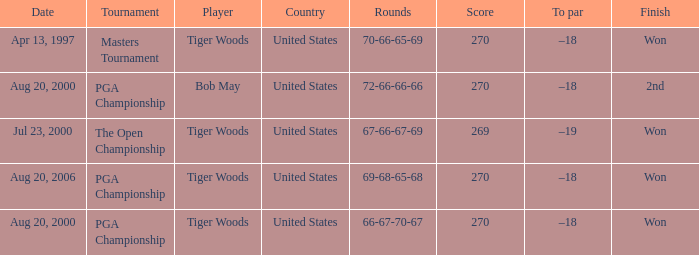What country hosts the tournament the open championship? United States. 